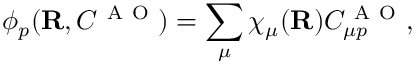Convert formula to latex. <formula><loc_0><loc_0><loc_500><loc_500>\phi _ { p } ( { R } , C ^ { A O } ) = \sum _ { \mu } \chi _ { \mu } ( { R } ) C _ { \mu p } ^ { A O } ,</formula> 